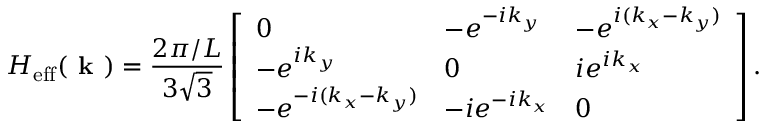Convert formula to latex. <formula><loc_0><loc_0><loc_500><loc_500>H _ { e f f } ( k ) = \frac { 2 \pi / L } { 3 \sqrt { 3 } } \left [ \begin{array} { l l l } { 0 } & { - e ^ { - i k _ { y } } } & { - e ^ { i ( k _ { x } - k _ { y } ) } } \\ { - e ^ { i k _ { y } } } & { 0 } & { i e ^ { i k _ { x } } } \\ { - e ^ { - i ( k _ { x } - k _ { y } ) } } & { - i e ^ { - i k _ { x } } } & { 0 } \end{array} \right ] .</formula> 